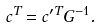<formula> <loc_0><loc_0><loc_500><loc_500>c ^ { T } = c ^ { \prime T } G ^ { - 1 } .</formula> 